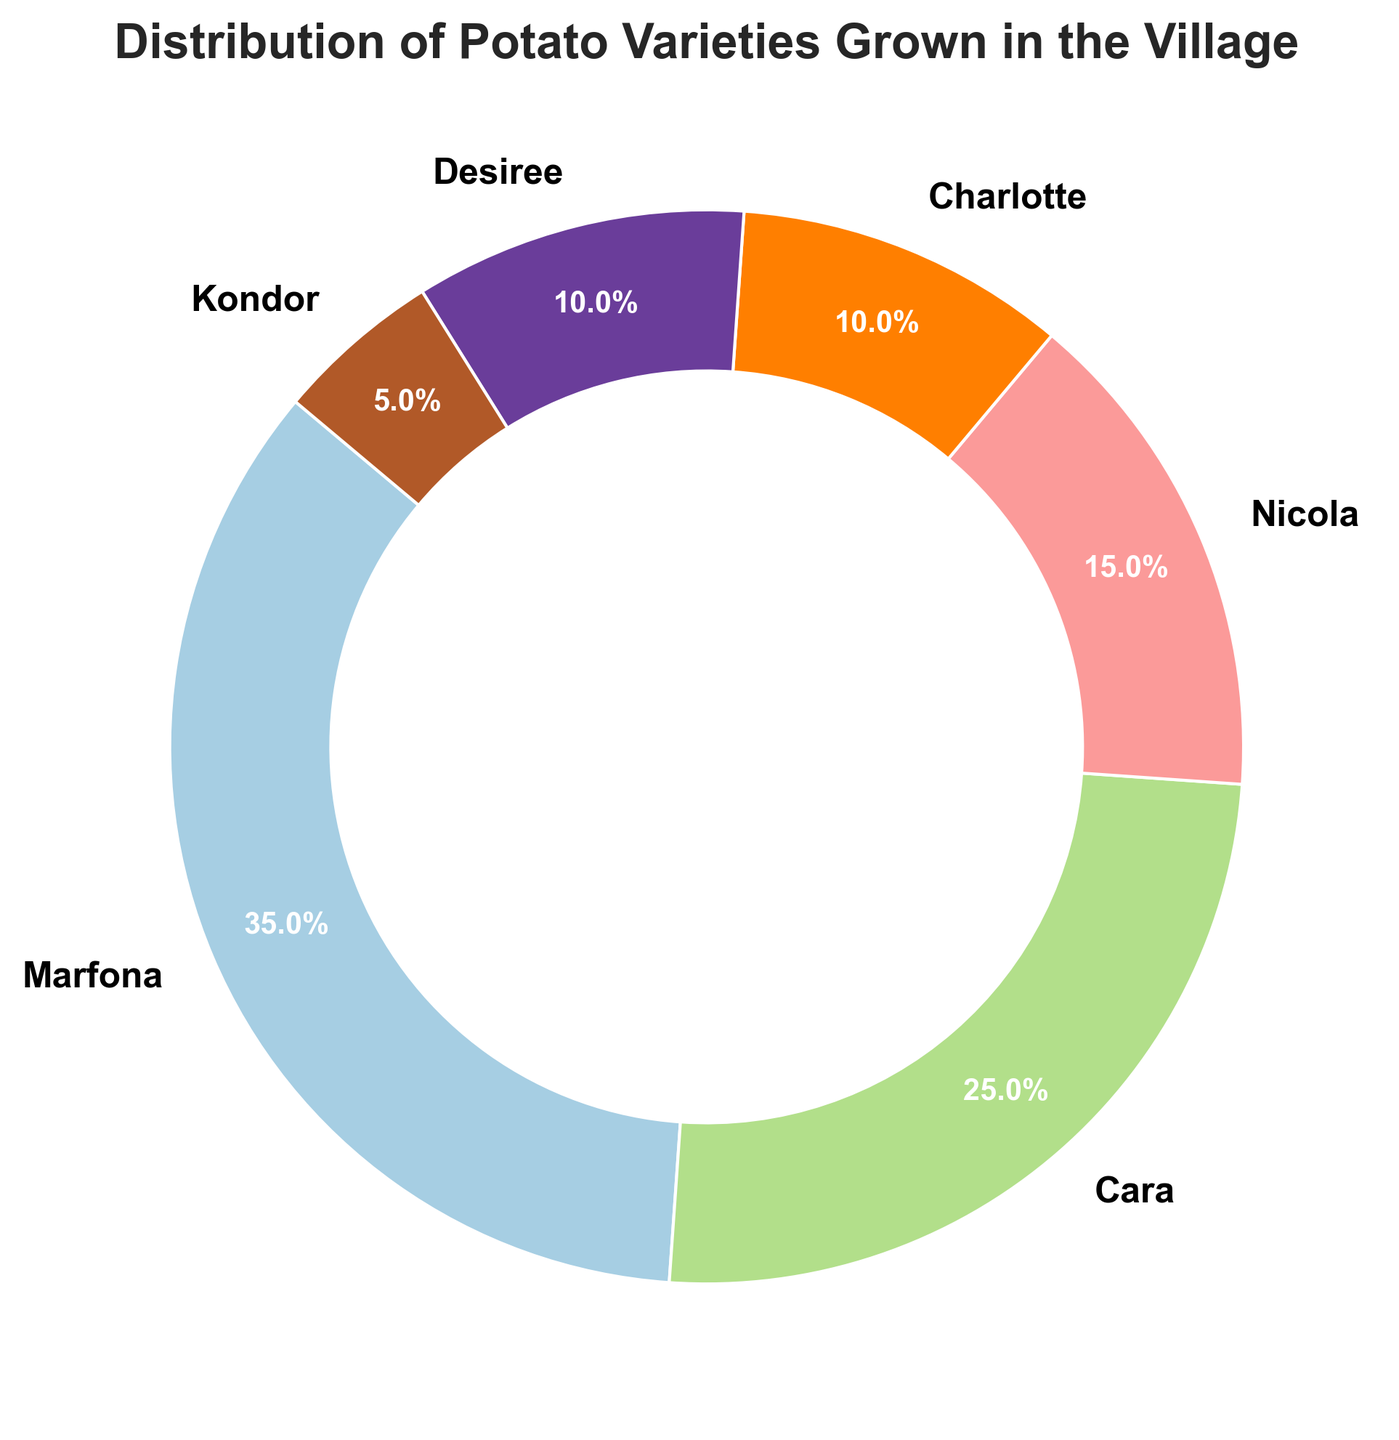What percentage of potato varieties grown in the village is represented by Marfona and Cara together? To find the total percentage for Marfona and Cara, simply add their individual percentages. Marfona is 35% and Cara is 25%. So, 35% + 25% = 60%.
Answer: 60% What is the least grown variety of potatoes in the village? Look at the slice with the smallest size or the label with the smallest percentage, which is Kondor at 5%.
Answer: Kondor Compare the percentages of Marfona and Nicola. Which variety is more common, and by how much? Marfona is 35% and Nicola is 15%. Subtract Nicola's percentage from Marfona's percentage: 35% - 15% = 20%.
Answer: Marfona is more common by 20% How much larger is the percentage of Desiree compared to Kondor? Desiree has 10% and Kondor has 5%. Subtract Kondor's percentage from Desiree's: 10% - 5% = 5%.
Answer: 5% What fraction of the potato varieties grown is represented by Charlotte and Kondor combined? Add the percentages of Charlotte (10%) and Kondor (5%): 10% + 5% = 15%. Then, since the total percentage is 100, the fraction is 15/100. Simplifying it, we get 3/20.
Answer: 3/20 Which variety of potatoes has the second-highest percentage? Find the second largest slice or percentage label after Marfona (35%). Cara has the second-highest at 25%.
Answer: Cara What is the combined percentage for all the potato varieties except Marfona? Add the percentages of all the varieties except Marfona: Cara (25%) + Nicola (15%) + Charlotte (10%) + Desiree (10%) + Kondor (5%) = 65%.
Answer: 65% Which two potato varieties together make up less than 20% of the total pie? Identify pairs of percentages that add up to less than 20%. Charlotte (10%) and Kondor (5%) together make 15%, which is less than 20%.
Answer: Charlotte and Kondor 